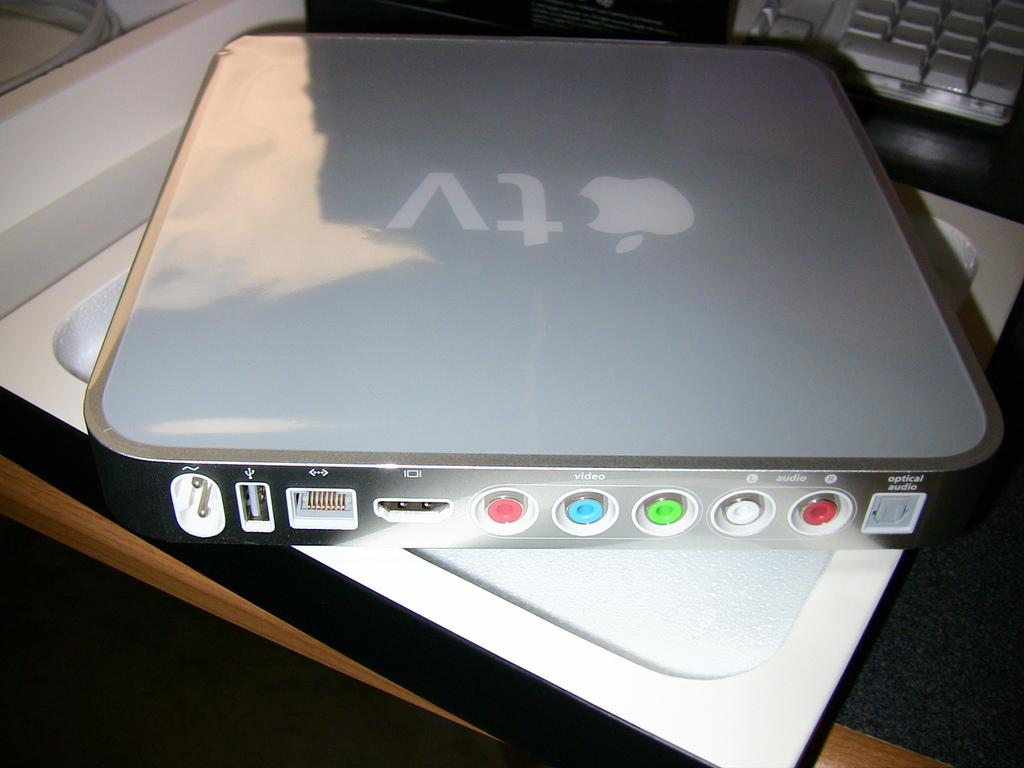<image>
Create a compact narrative representing the image presented. an apple tv box showing the back panel next to a keyboard. 